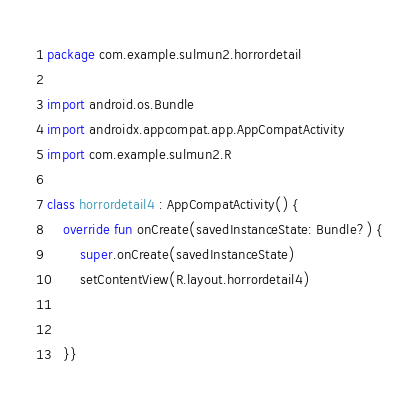<code> <loc_0><loc_0><loc_500><loc_500><_Kotlin_>package com.example.sulmun2.horrordetail

import android.os.Bundle
import androidx.appcompat.app.AppCompatActivity
import com.example.sulmun2.R

class horrordetail4 : AppCompatActivity() {
    override fun onCreate(savedInstanceState: Bundle?) {
        super.onCreate(savedInstanceState)
        setContentView(R.layout.horrordetail4)


    }}
</code> 